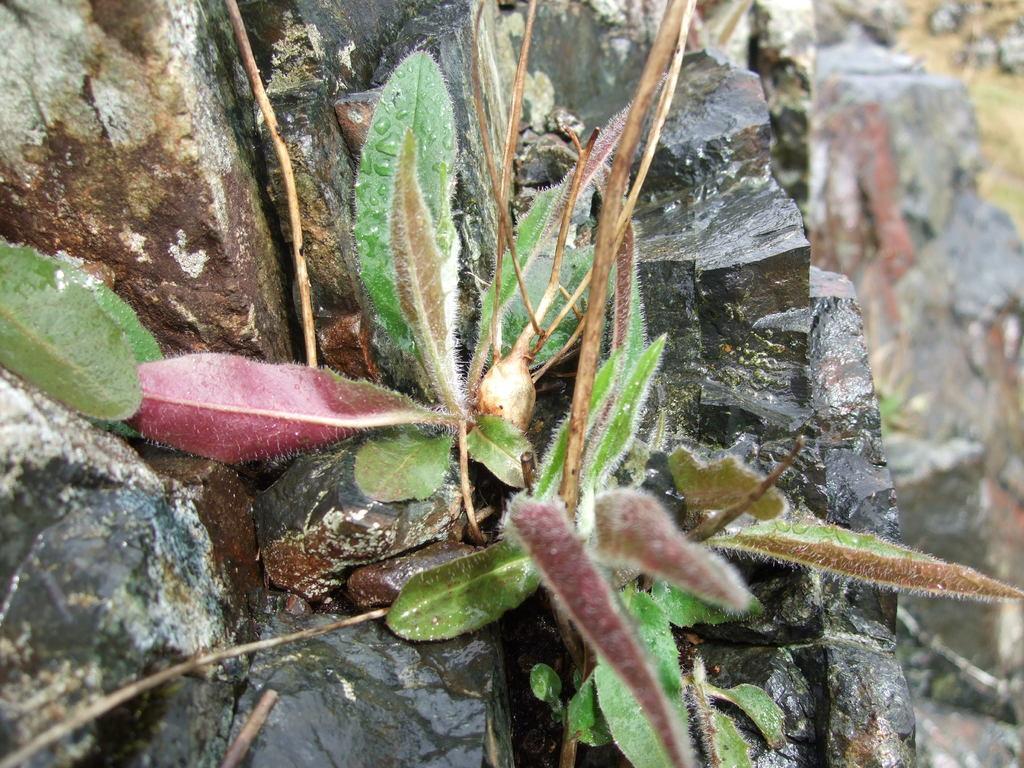How would you summarize this image in a sentence or two? This picture shows a plant and we see a rock. 